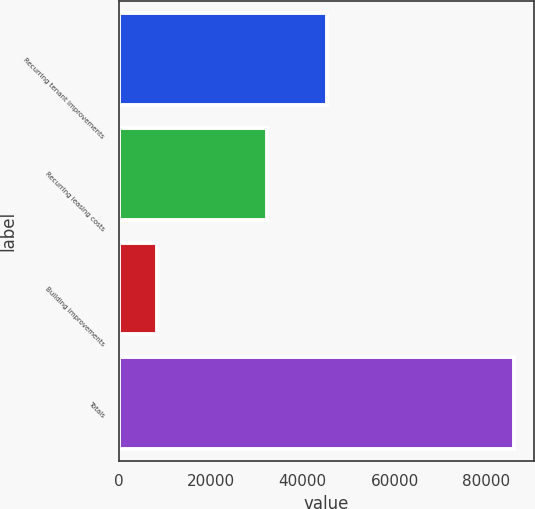<chart> <loc_0><loc_0><loc_500><loc_500><bar_chart><fcel>Recurring tenant improvements<fcel>Recurring leasing costs<fcel>Building improvements<fcel>Totals<nl><fcel>45296<fcel>32238<fcel>8402<fcel>85936<nl></chart> 